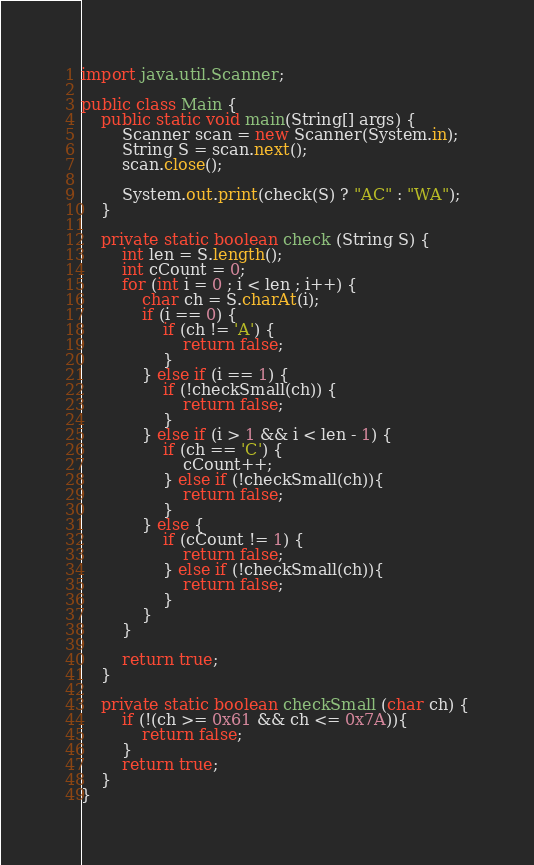<code> <loc_0><loc_0><loc_500><loc_500><_Java_>import java.util.Scanner;

public class Main {
	public static void main(String[] args) {
		Scanner scan = new Scanner(System.in);
		String S = scan.next();
		scan.close();
		
		System.out.print(check(S) ? "AC" : "WA"); 
	}
	
	private static boolean check (String S) {
		int len = S.length();
		int cCount = 0;
		for (int i = 0 ; i < len ; i++) {
			char ch = S.charAt(i);
			if (i == 0) {
				if (ch != 'A') {
					return false;					
				}
			} else if (i == 1) {
				if (!checkSmall(ch)) {
					return false;
				}
			} else if (i > 1 && i < len - 1) {
				if (ch == 'C') {
					cCount++;
				} else if (!checkSmall(ch)){
					return false;
				}
			} else {
				if (cCount != 1) {
					return false;
				} else if (!checkSmall(ch)){
					return false;
				}
			}
		}
		
		return true;
	}
	
	private static boolean checkSmall (char ch) {
		if (!(ch >= 0x61 && ch <= 0x7A)){
			return false;
		}
		return true;
	}
}</code> 